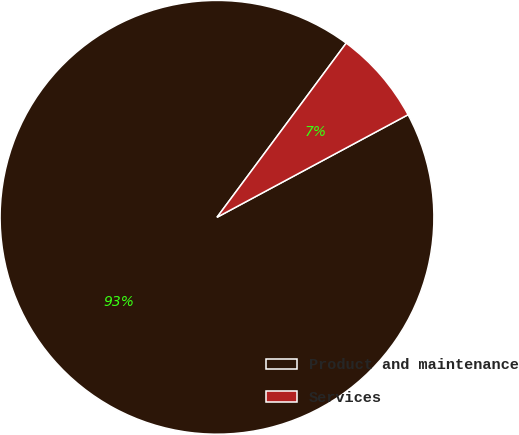Convert chart. <chart><loc_0><loc_0><loc_500><loc_500><pie_chart><fcel>Product and maintenance<fcel>Services<nl><fcel>93.0%<fcel>7.0%<nl></chart> 